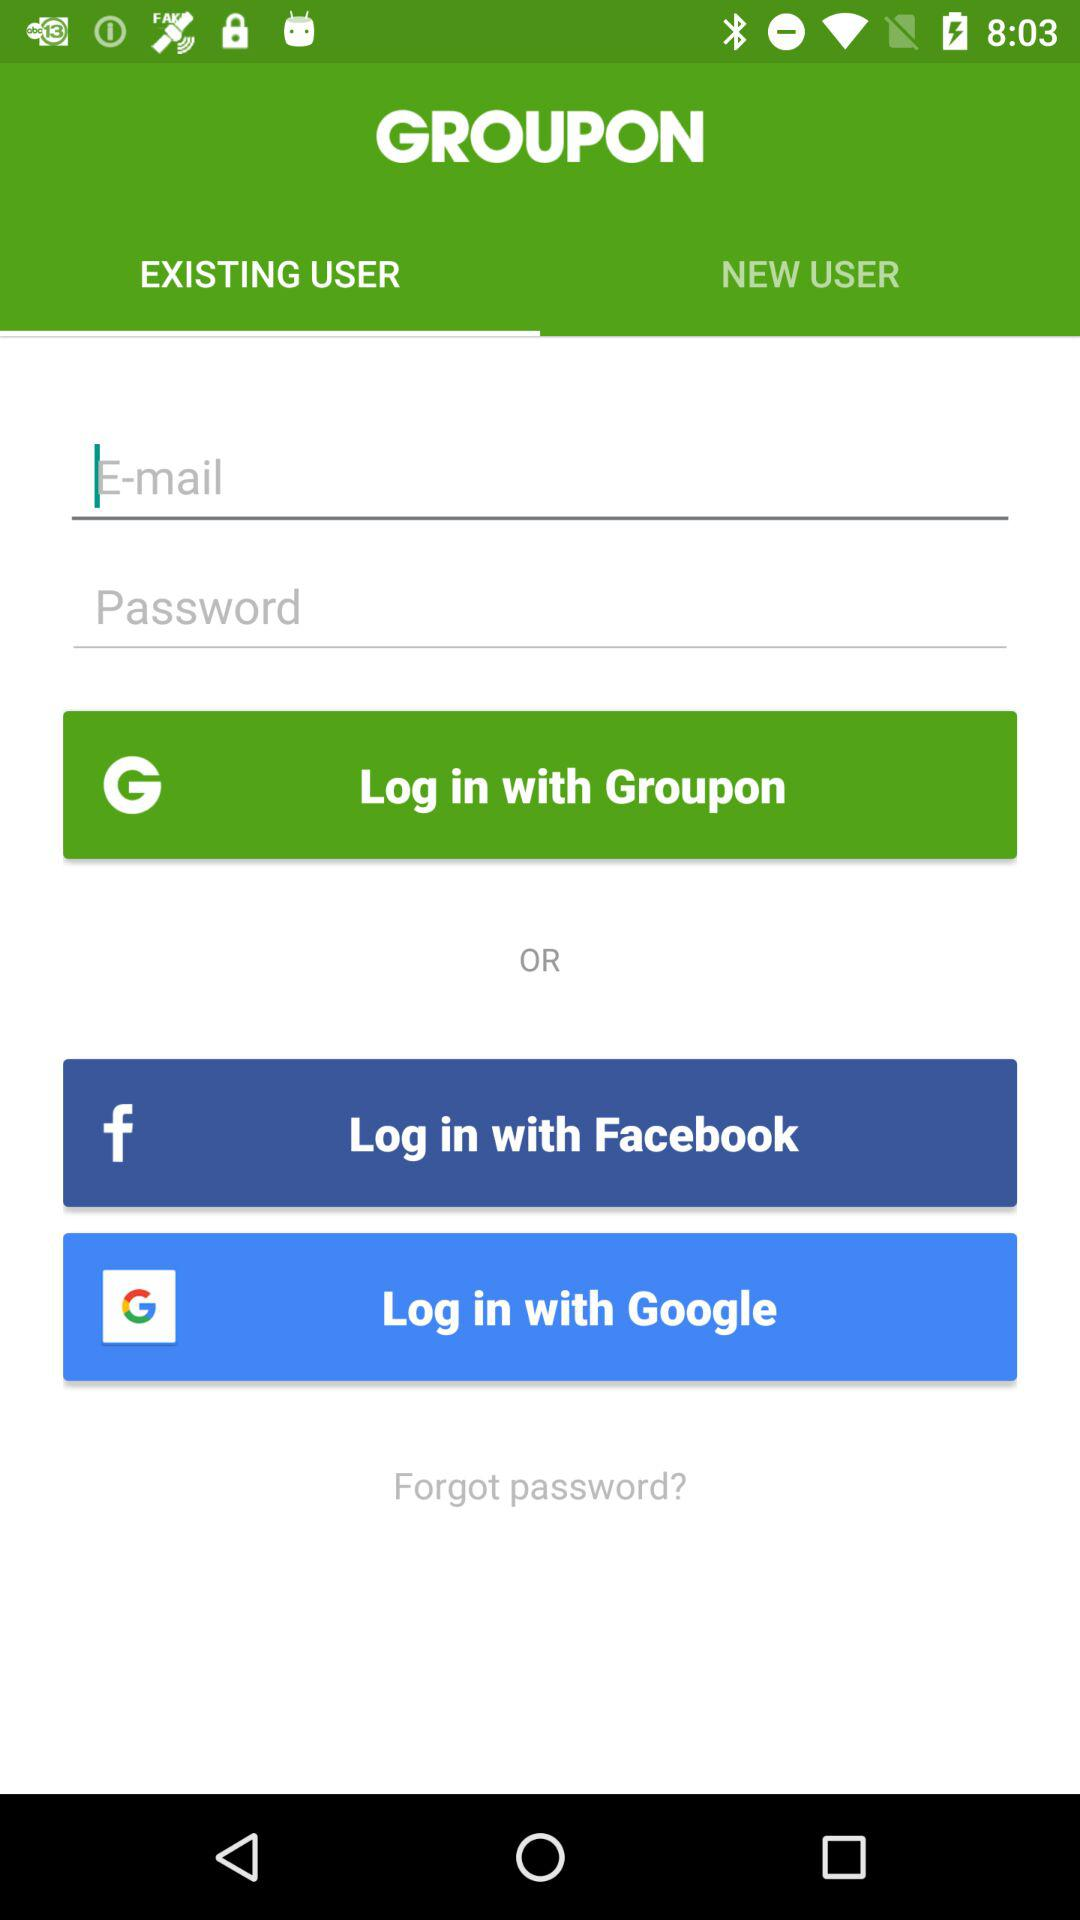What are the names of the accounts through which logging in can be done? The names of the accounts through which logging in can be done are "Groupon", "Facebook" and "Google". 